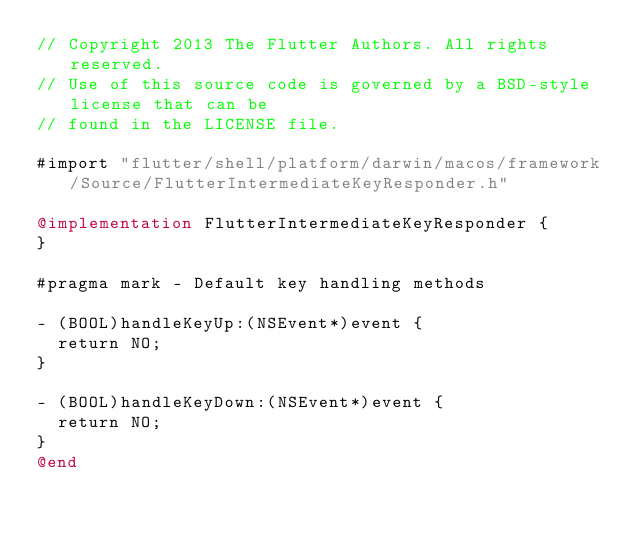Convert code to text. <code><loc_0><loc_0><loc_500><loc_500><_ObjectiveC_>// Copyright 2013 The Flutter Authors. All rights reserved.
// Use of this source code is governed by a BSD-style license that can be
// found in the LICENSE file.

#import "flutter/shell/platform/darwin/macos/framework/Source/FlutterIntermediateKeyResponder.h"

@implementation FlutterIntermediateKeyResponder {
}

#pragma mark - Default key handling methods

- (BOOL)handleKeyUp:(NSEvent*)event {
  return NO;
}

- (BOOL)handleKeyDown:(NSEvent*)event {
  return NO;
}
@end
</code> 